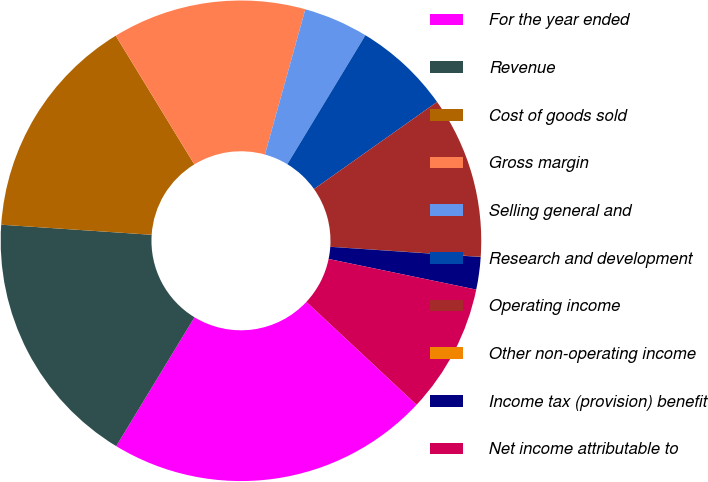Convert chart to OTSL. <chart><loc_0><loc_0><loc_500><loc_500><pie_chart><fcel>For the year ended<fcel>Revenue<fcel>Cost of goods sold<fcel>Gross margin<fcel>Selling general and<fcel>Research and development<fcel>Operating income<fcel>Other non-operating income<fcel>Income tax (provision) benefit<fcel>Net income attributable to<nl><fcel>21.73%<fcel>17.38%<fcel>15.21%<fcel>13.04%<fcel>4.35%<fcel>6.53%<fcel>10.87%<fcel>0.01%<fcel>2.18%<fcel>8.7%<nl></chart> 